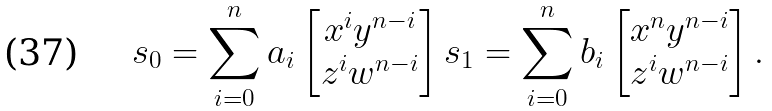<formula> <loc_0><loc_0><loc_500><loc_500>s _ { 0 } = \sum _ { i = 0 } ^ { n } a _ { i } \begin{bmatrix} x ^ { i } y ^ { n - i } \\ z ^ { i } w ^ { n - i } \end{bmatrix} s _ { 1 } & = \sum _ { i = 0 } ^ { n } b _ { i } \begin{bmatrix} x ^ { n } y ^ { n - i } \\ z ^ { i } w ^ { n - i } \end{bmatrix} .</formula> 